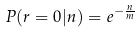Convert formula to latex. <formula><loc_0><loc_0><loc_500><loc_500>P ( r = 0 | n ) = e ^ { - \frac { n } { m } }</formula> 